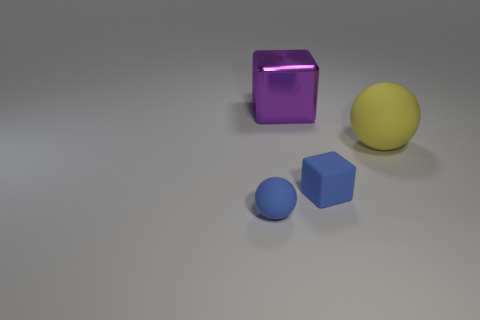The tiny rubber thing that is the same color as the small rubber sphere is what shape?
Ensure brevity in your answer.  Cube. What number of other purple cubes have the same size as the purple cube?
Make the answer very short. 0. What number of yellow matte things are left of the blue cube?
Make the answer very short. 0. What material is the sphere that is on the right side of the ball on the left side of the yellow object?
Ensure brevity in your answer.  Rubber. Is there a matte cube that has the same color as the large shiny object?
Your answer should be very brief. No. There is a blue block that is the same material as the yellow thing; what is its size?
Your answer should be compact. Small. Is there anything else that has the same color as the small matte sphere?
Give a very brief answer. Yes. The rubber sphere on the right side of the big metal thing is what color?
Offer a very short reply. Yellow. Is there a yellow matte ball that is to the left of the tiny object on the right side of the tiny blue ball to the left of the tiny blue rubber cube?
Ensure brevity in your answer.  No. Is the number of tiny blue rubber spheres that are in front of the small sphere greater than the number of large cyan shiny balls?
Your answer should be compact. No. 